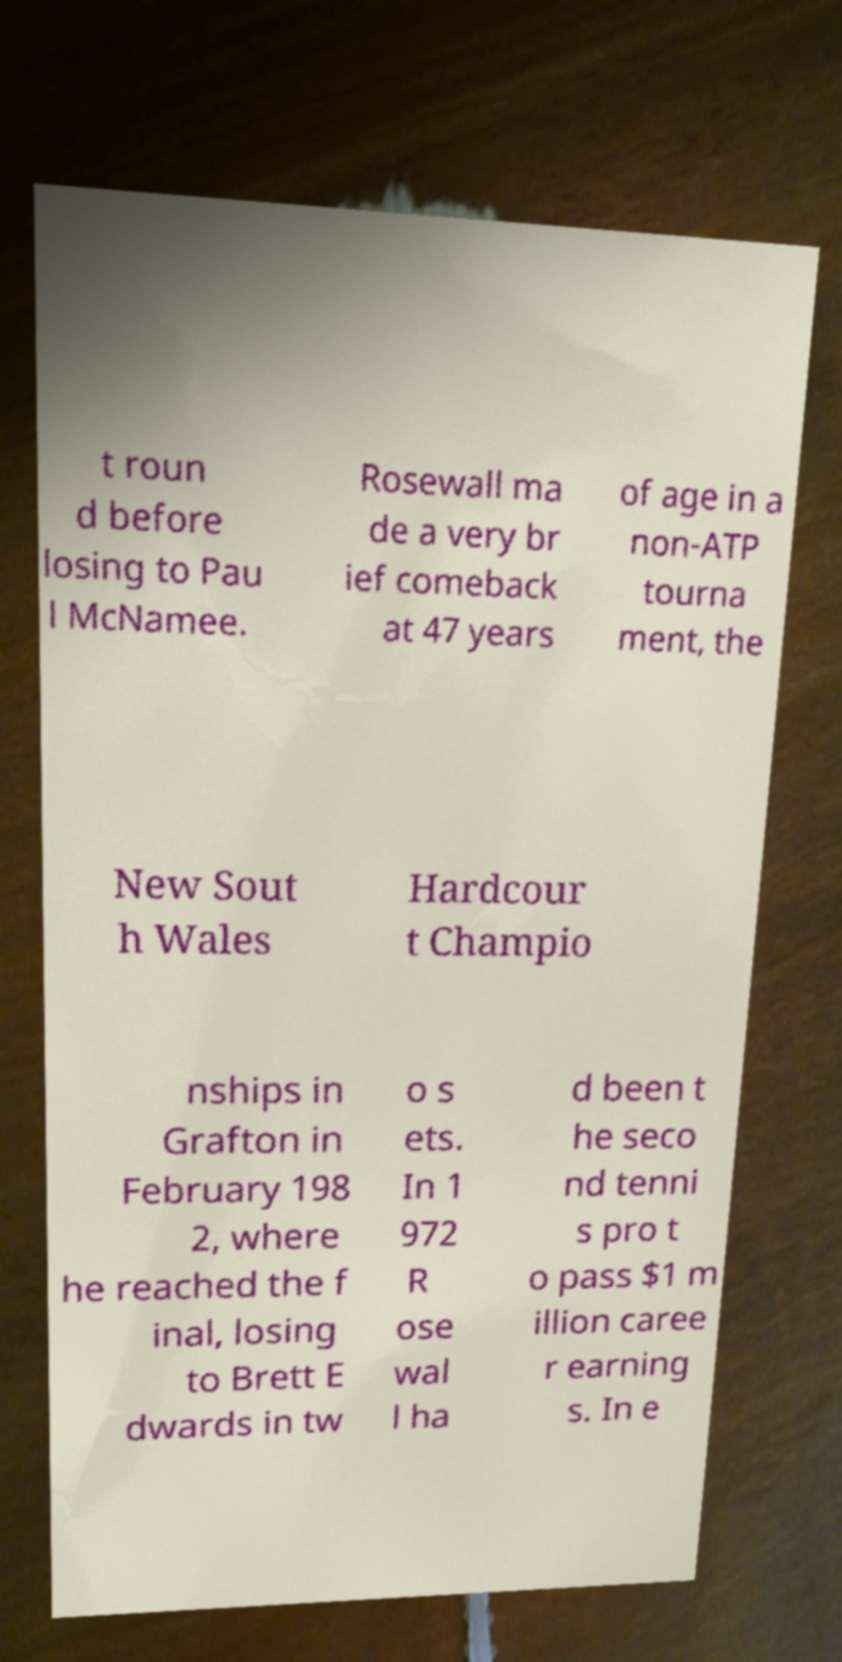Can you read and provide the text displayed in the image?This photo seems to have some interesting text. Can you extract and type it out for me? t roun d before losing to Pau l McNamee. Rosewall ma de a very br ief comeback at 47 years of age in a non-ATP tourna ment, the New Sout h Wales Hardcour t Champio nships in Grafton in February 198 2, where he reached the f inal, losing to Brett E dwards in tw o s ets. In 1 972 R ose wal l ha d been t he seco nd tenni s pro t o pass $1 m illion caree r earning s. In e 